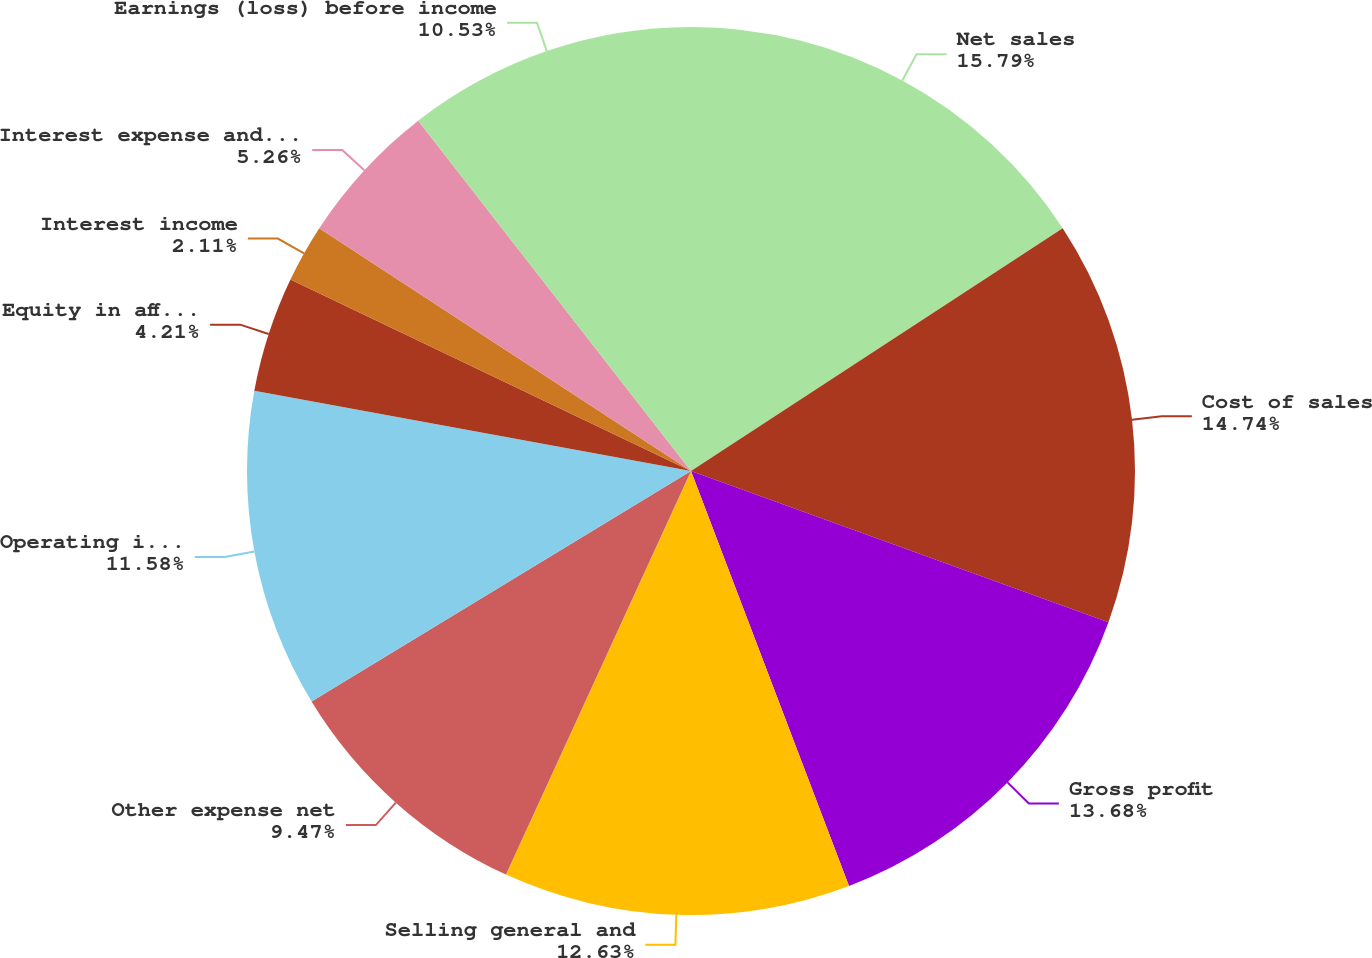Convert chart to OTSL. <chart><loc_0><loc_0><loc_500><loc_500><pie_chart><fcel>Net sales<fcel>Cost of sales<fcel>Gross profit<fcel>Selling general and<fcel>Other expense net<fcel>Operating income (loss)<fcel>Equity in affiliates' earnings<fcel>Interest income<fcel>Interest expense and finance<fcel>Earnings (loss) before income<nl><fcel>15.79%<fcel>14.74%<fcel>13.68%<fcel>12.63%<fcel>9.47%<fcel>11.58%<fcel>4.21%<fcel>2.11%<fcel>5.26%<fcel>10.53%<nl></chart> 